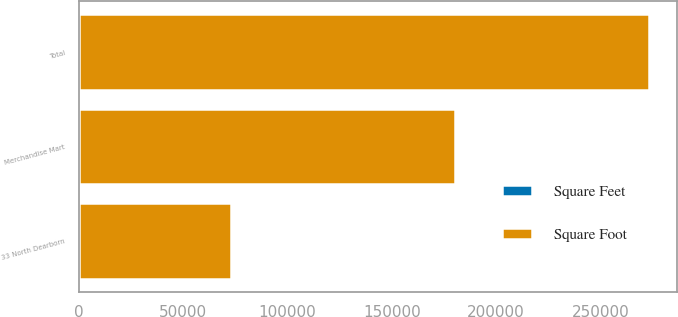Convert chart to OTSL. <chart><loc_0><loc_0><loc_500><loc_500><stacked_bar_chart><ecel><fcel>Merchandise Mart<fcel>33 North Dearborn<fcel>Total<nl><fcel>Square Foot<fcel>180000<fcel>73000<fcel>273000<nl><fcel>Square Feet<fcel>22.45<fcel>23.11<fcel>24.17<nl></chart> 